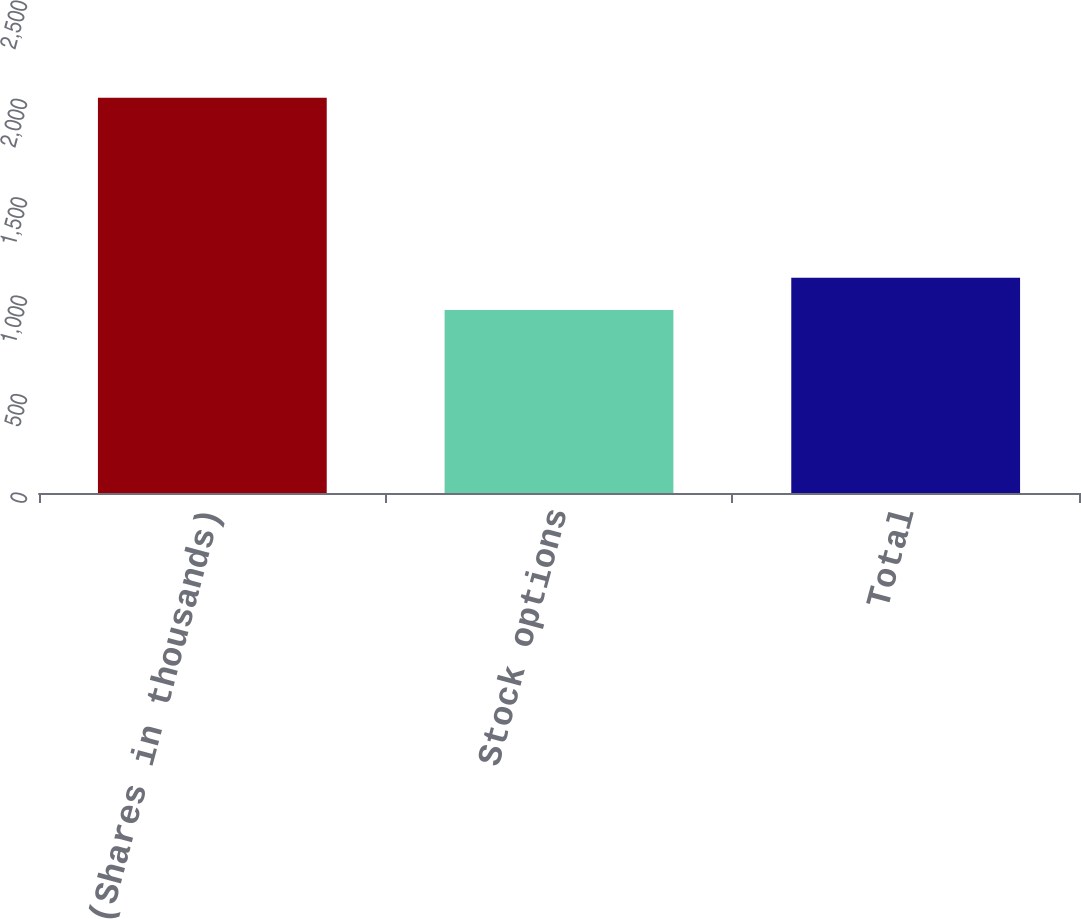Convert chart to OTSL. <chart><loc_0><loc_0><loc_500><loc_500><bar_chart><fcel>(Shares in thousands)<fcel>Stock options<fcel>Total<nl><fcel>2008<fcel>930<fcel>1094<nl></chart> 